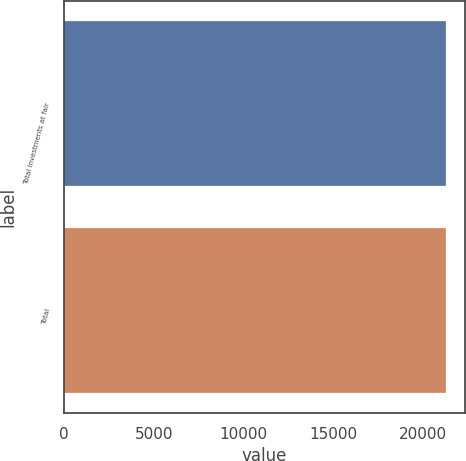Convert chart. <chart><loc_0><loc_0><loc_500><loc_500><bar_chart><fcel>Total investments at fair<fcel>Total<nl><fcel>21283<fcel>21283.1<nl></chart> 